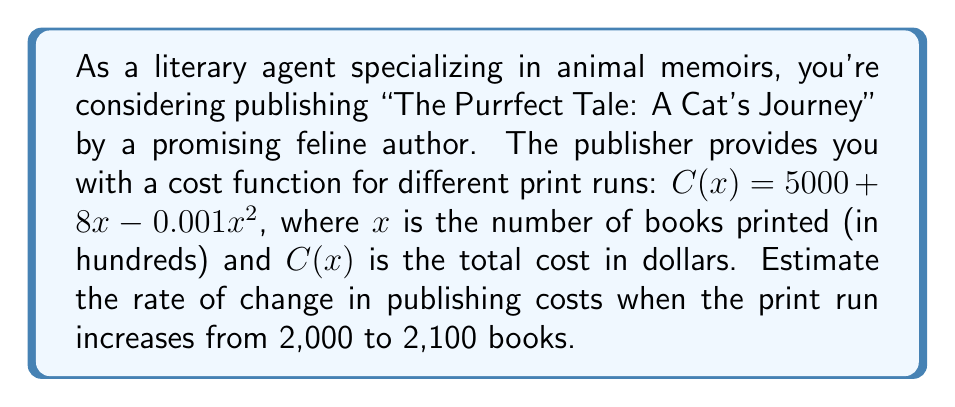Could you help me with this problem? To estimate the rate of change, we'll use the average rate of change formula:

$$\text{Average rate of change} = \frac{C(x_2) - C(x_1)}{x_2 - x_1}$$

1. Convert the book quantities to hundreds:
   2,000 books = 20 hundreds
   2,100 books = 21 hundreds

2. Calculate $C(20)$:
   $$C(20) = 5000 + 8(20) - 0.001(20)^2 = 5000 + 160 - 4 = 5156$$

3. Calculate $C(21)$:
   $$C(21) = 5000 + 8(21) - 0.001(21)^2 = 5000 + 168 - 4.41 = 5163.59$$

4. Apply the average rate of change formula:
   $$\text{Average rate of change} = \frac{5163.59 - 5156}{21 - 20} = \frac{7.59}{1} = 7.59$$

5. Interpret the result:
   The rate of change is $7.59 per hundred books, or $0.0759 per book.
Answer: $7.59 per 100 books 